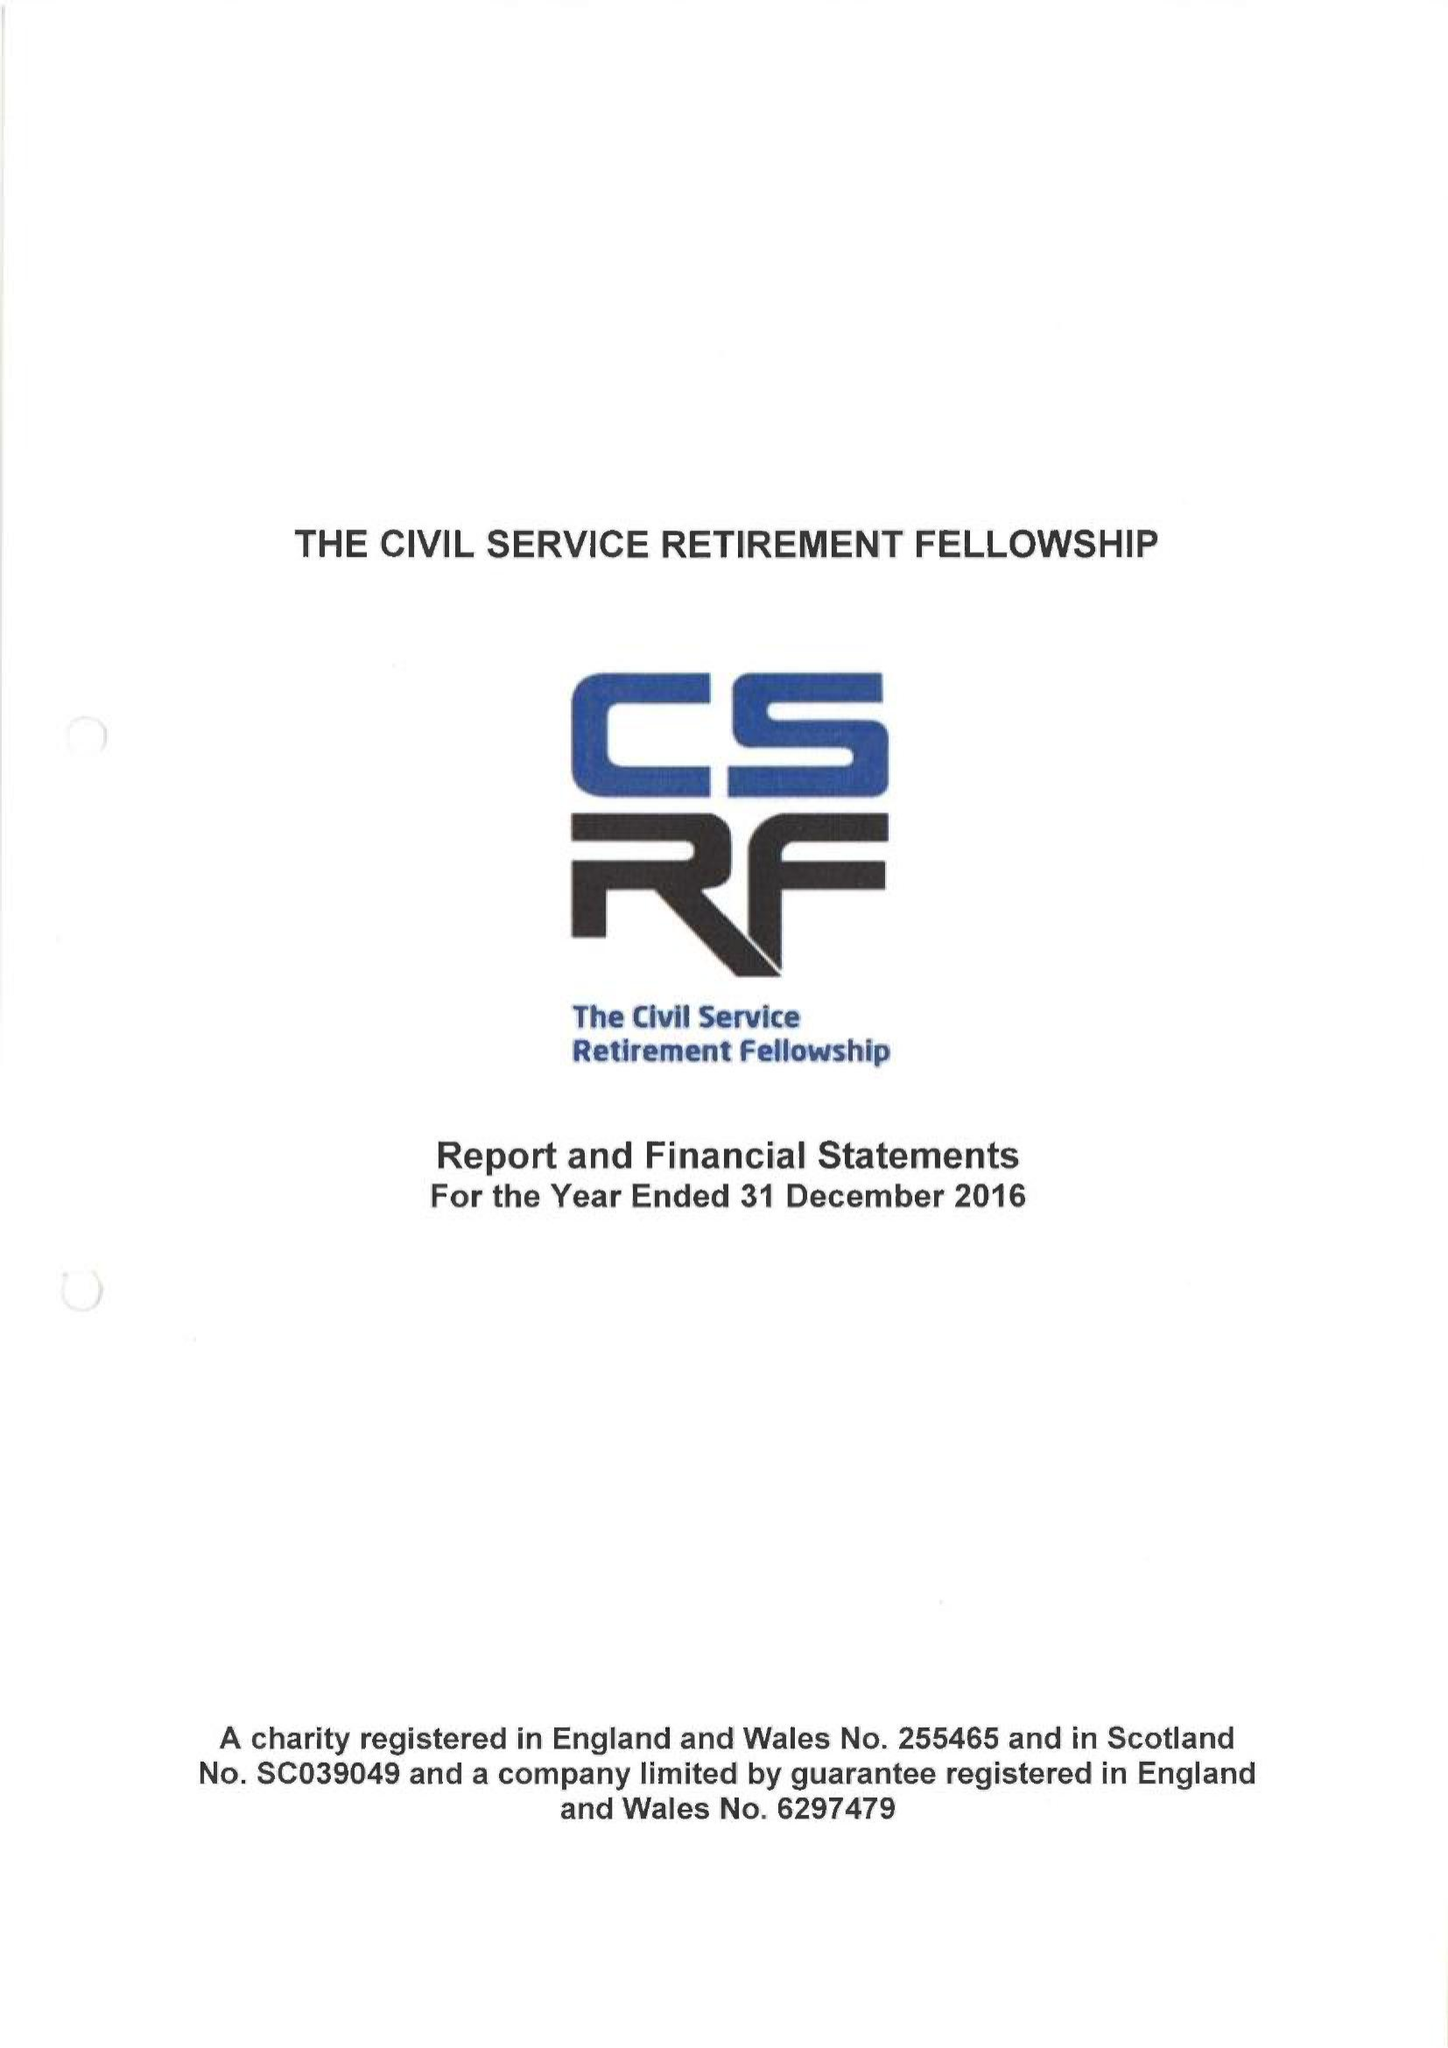What is the value for the income_annually_in_british_pounds?
Answer the question using a single word or phrase. 394543.00 